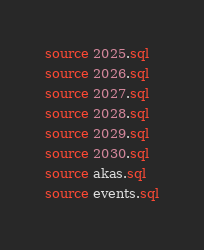Convert code to text. <code><loc_0><loc_0><loc_500><loc_500><_SQL_>source 2025.sql
source 2026.sql
source 2027.sql
source 2028.sql
source 2029.sql
source 2030.sql
source akas.sql
source events.sql
</code> 